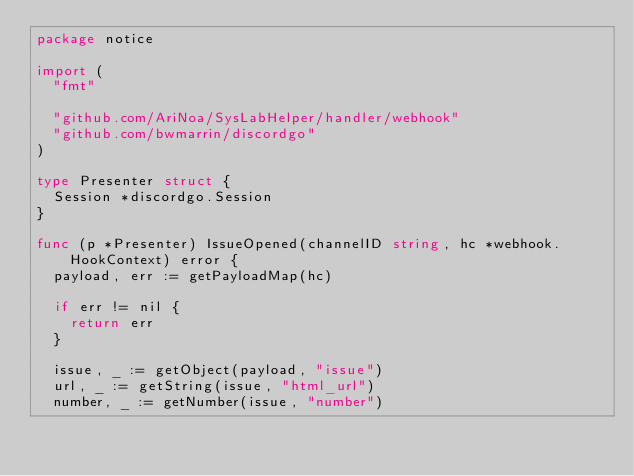Convert code to text. <code><loc_0><loc_0><loc_500><loc_500><_Go_>package notice

import (
	"fmt"

	"github.com/AriNoa/SysLabHelper/handler/webhook"
	"github.com/bwmarrin/discordgo"
)

type Presenter struct {
	Session *discordgo.Session
}

func (p *Presenter) IssueOpened(channelID string, hc *webhook.HookContext) error {
	payload, err := getPayloadMap(hc)

	if err != nil {
		return err
	}

	issue, _ := getObject(payload, "issue")
	url, _ := getString(issue, "html_url")
	number, _ := getNumber(issue, "number")</code> 